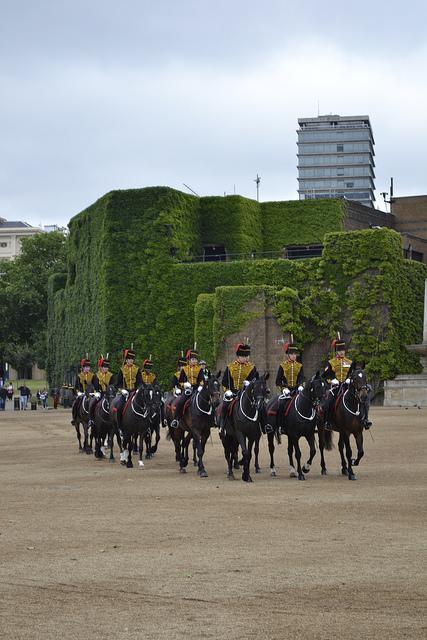How many horses are in the picture?
Give a very brief answer. 5. 